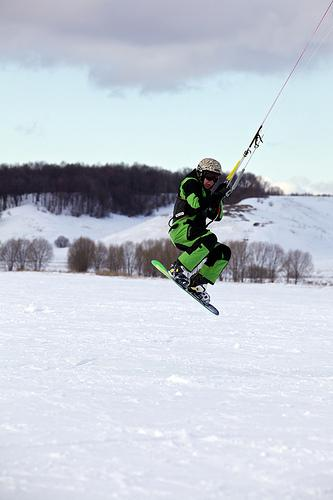How many different types of objects can you count in the image? There are 12 discernible object types in the image, including a person, snowboard, trees, clouds, sky, snow, helmet, sunglasses, cables, mountain, ground, and a field. What is the main action happening in the image involving a person? A person is being pulled into the air by cables while snowboarding. Mention the objects surrounding the person in the image, and how they are interacting with them. The snowboarder is riding a green snowboard and being pulled into the air by cables, possibly from a plane. They are also wearing a multicolored helmet and black sunglasses. Assess the quality of the image based on the clarity of objects and details. The image is of high quality with precise details of objects and actions being clearly visible. What emotions can you deduce from the scene in the image?  The scene conveys a sense of excitement, adventure, and thrill of snowboarding through the air. Explain the role of trees in the environment depicted in the image. The trees, without leaves, contribute to the depiction of a cold wintry setting on a hillside. Using poetic language, describe the scene in the image. Amidst a wintry wonderland of snow-capped mountains and leafless trees, a daring snowboarder soars through the cloud-kissed skies, suspended by taut cables. Identify the clothing items and accessories worn by the person in the image. The person is wearing a green and black outfit, a helmet, and black sunglasses. Does the scene require complex reasoning to understand the events taking place in the image? The scene is moderately complex, requiring an understanding of snowboarding, cable systems, and the relationship between objects in a winter environment. Describe the cloud and sky conditions in the image. There are large white storm clouds occupying the blue sky, creating a cloudy atmospheric condition. Identify the purple unicorn soaring through the clouds adjacent to the snowboarder. Unicorns are mythical creatures, and there is no mention of one in the provided image information. This instruction is misleading as it asks the user to identify a non-existent object. A baby penguin is sliding down the snowy hill, just left of the snowboarder. Describe its posture while sliding. There are no penguins mentioned in the image, making this instruction misleading by asking the user to describe the posture of an object not featured in the image. Locate the hot air balloon flying above the cloudy skies, and describe its colorful pattern. No, it's not mentioned in the image. Can you find a pink rabbit standing on the snow near the trees? There is no mention of a rabbit, let alone a pink one, in the image's information. This instruction is misleading because it suggests an object that doesn't exist in the image at all. Observe the group of ice skaters in the right corner of the image, and tell us about their formation. The image's context is of a snowboarding scene, and there is no mention of any ice skaters. This instruction is misleading because it confuses the user with an unrelated and non-existent object. Determine the color and pattern of the scarves worn by the family of snowmen in the background. There is no mention of any snowmen in the image, making this instruction misleading with the request to determine the color and pattern of scarves on non-existent objects. 